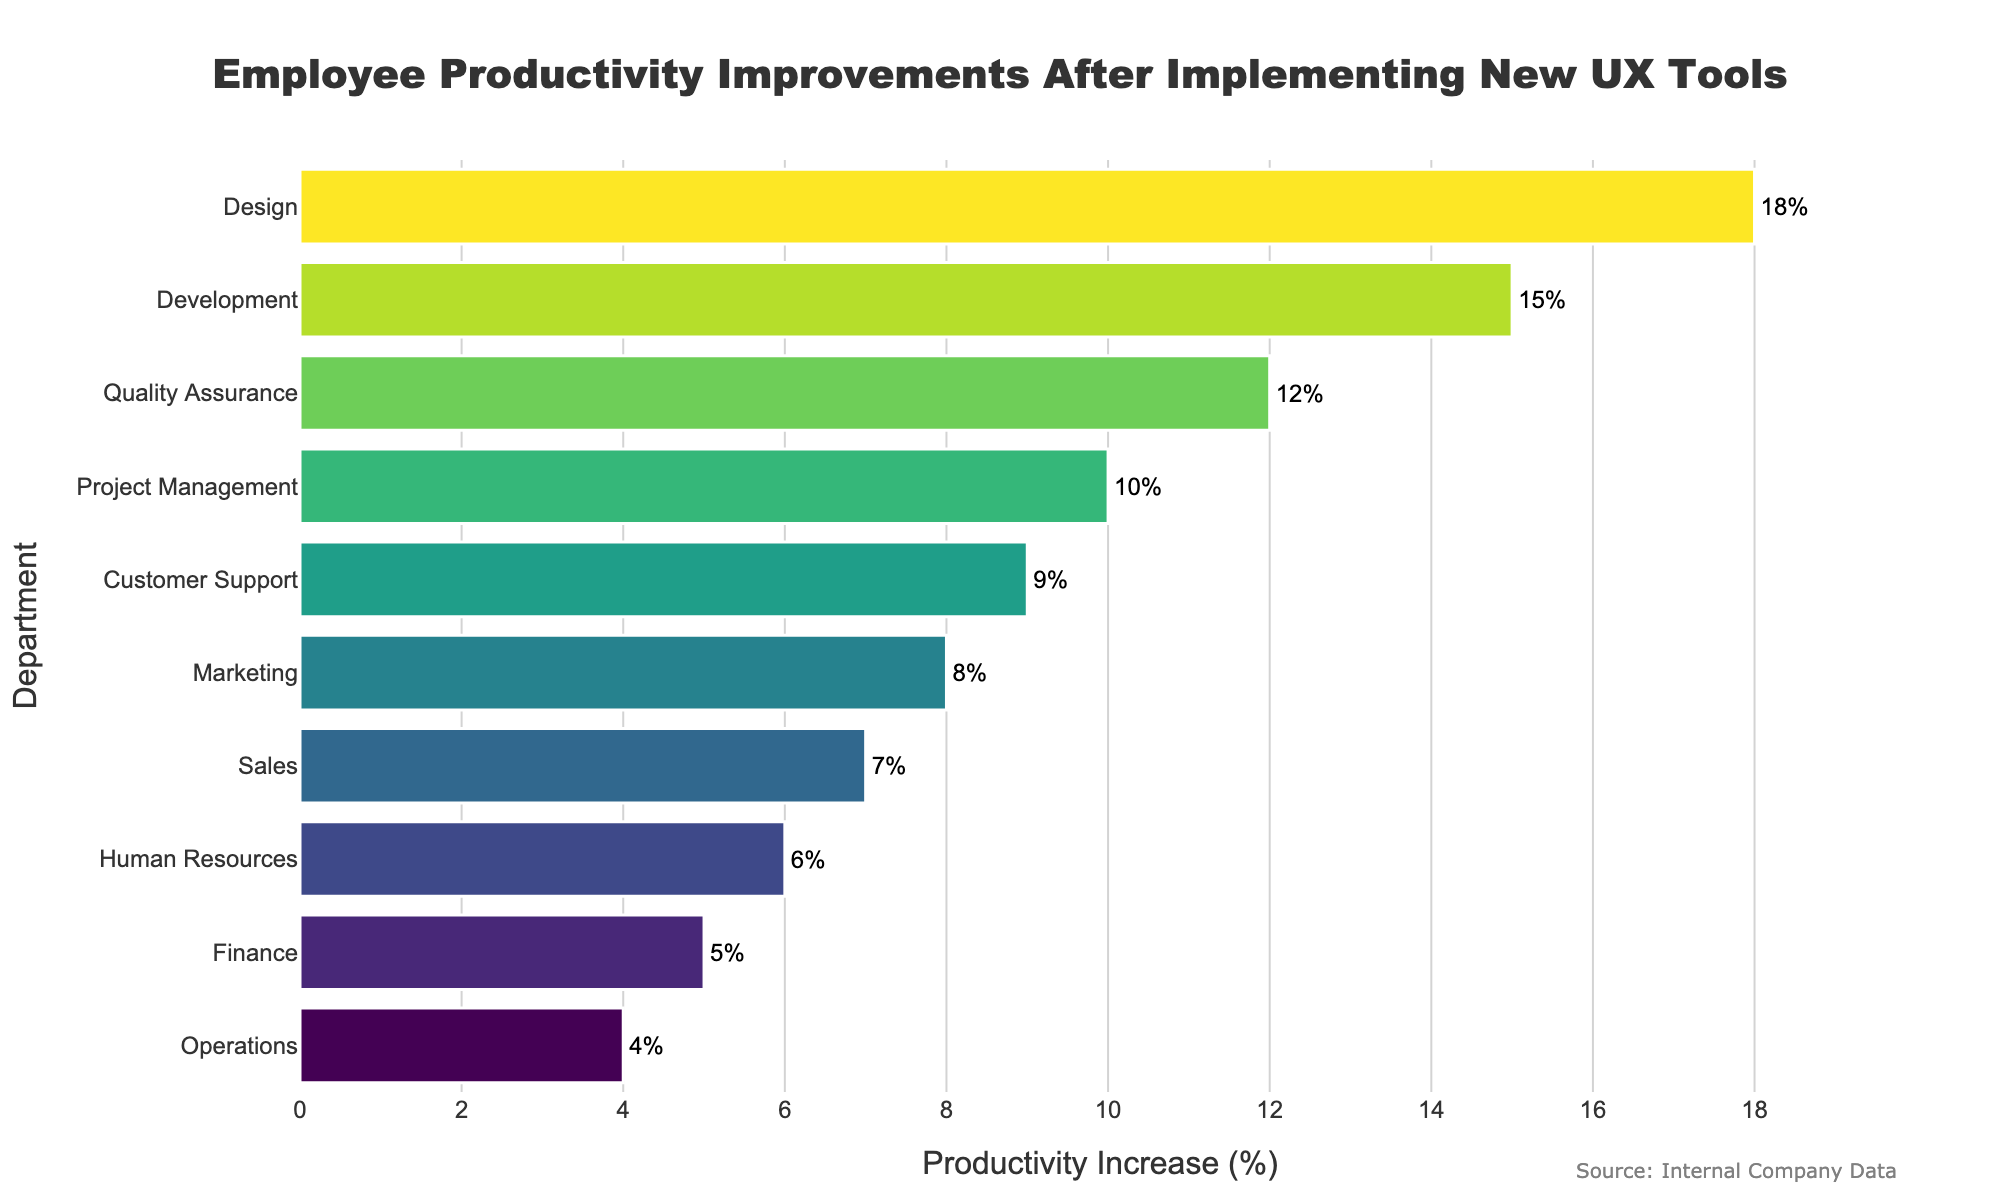What is the department with the highest productivity increase percentage after implementing new UX tools? The Design department has the highest productivity increase. This is determined by looking at the bar that stretches the furthest to the right on the horizontal axis, indicating the highest percentage increase.
Answer: Design Which department has a lower productivity improvement, Marketing or Customer Support? By comparing the length of the bars, Customer Support has a productivity increase of 9%, while Marketing has 8%. Since 8% is less than 9%, Marketing has a lower productivity improvement.
Answer: Marketing What is the total productivity increase percentage contributed by the top three departments? The top three departments by productivity increase percentage are Design (18%), Development (15%), and Quality Assurance (12%). Summing these values: 18% + 15% + 12% = 45%.
Answer: 45% How does the productivity increase in Sales compare to that in Human Resources? The bar for Sales shows a productivity increase of 7%, and the bar for Human Resources shows 6%. Since 7% is greater than 6%, Sales has a higher productivity increase than Human Resources.
Answer: Sales What is the average productivity improvement percentage across all departments? To find the average productivity increase: (18 + 15 + 12 + 10 + 9 + 8 + 7 + 6 + 5 + 4) / 10 = 94 / 10 = 9.4%.
Answer: 9.4% Which department's productivity increase is exactly double that of Operations? Operations has a productivity increase of 4%. The department whose productivity increase is double that of Operations is Quality Assurance with an increase of 8%.
Answer: Quality Assurance If the productivity increases of Finance and Marketing are combined, do they exceed that of Project Management? Finance has a 5% increase and Marketing has 8%. Combined, this totals to 13% (5% + 8%). Project Management has a 10% increase. Therefore, the combined increase of Finance and Marketing (13%) exceeds that of Project Management (10%).
Answer: Yes What is the difference in productivity improvement between the Design and Finance departments? The Design department has an 18% productivity increase, and the Finance department has a 5% increase. The difference between these two values is 18% - 5% = 13%.
Answer: 13% How does the productivity increase of Customer Support compare across the distribution? Customer Support is in the upper-middle range with a 9% productivity increase. It is higher than Sales, Human Resources, Finance, and Operations but lower than Design, Development, Quality Assurance, and Project Management.
Answer: Upper-middle What trend can be observed from the productivity improvements across different departments? The figure shows that productivity improvements generally decrease from top to bottom. Design, Development, and Quality Assurance see the highest increases, while Operations, Finance, and Human Resources see the lowest. This trend may suggest that departments directly involved in user experience and product development benefit most from the UX tools.
Answer: Decreasing trend 